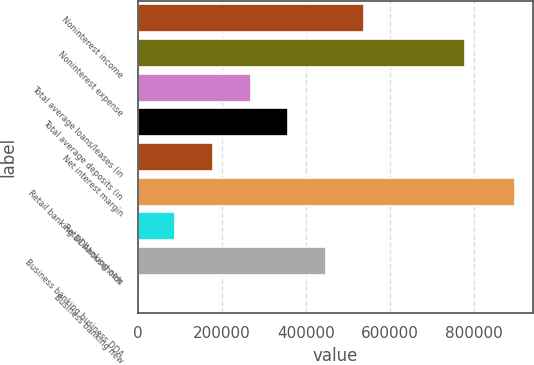<chart> <loc_0><loc_0><loc_500><loc_500><bar_chart><fcel>Noninterest income<fcel>Noninterest expense<fcel>Total average loans/leases (in<fcel>Total average deposits (in<fcel>Net interest margin<fcel>Retail banking DDAhouseholds<fcel>Retail banking new<fcel>Business banking business DDA<fcel>Business banking new<nl><fcel>537848<fcel>779010<fcel>268925<fcel>358566<fcel>179284<fcel>896412<fcel>89643<fcel>448207<fcel>2.03<nl></chart> 